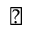Convert formula to latex. <formula><loc_0><loc_0><loc_500><loc_500>\diagdown</formula> 